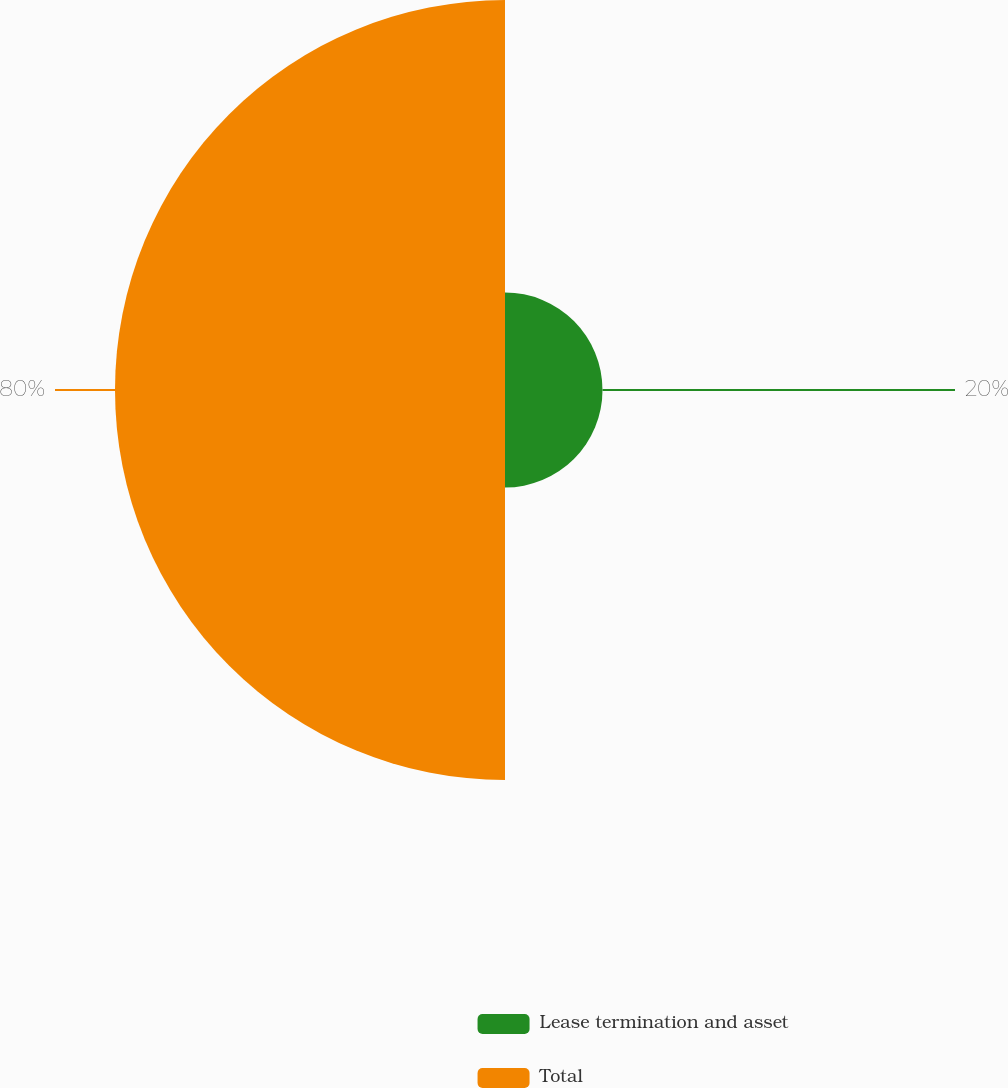<chart> <loc_0><loc_0><loc_500><loc_500><pie_chart><fcel>Lease termination and asset<fcel>Total<nl><fcel>20.0%<fcel>80.0%<nl></chart> 